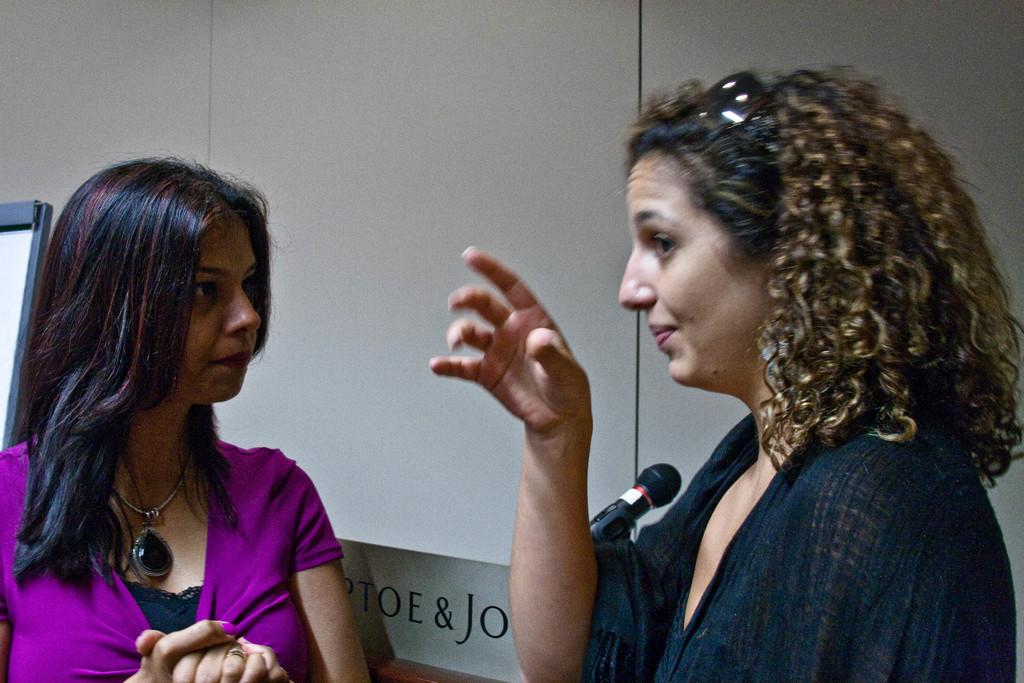How many women are in the foreground of the picture? There are two women standing in the foreground of the picture. What is behind the women in the image? There is a wall behind the women. What object is in the center of the image? There is a microphone in the center of the image. What can be seen on the left side of the image? There is a board on the left side of the image. What type of comfort can be seen on the stove in the image? There is no stove present in the image, so it is not possible to determine what type of comfort might be seen on it. 